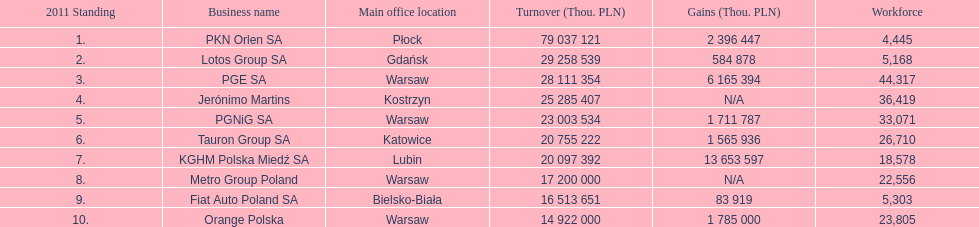What is the employee count at pgnig sa? 33,071. 